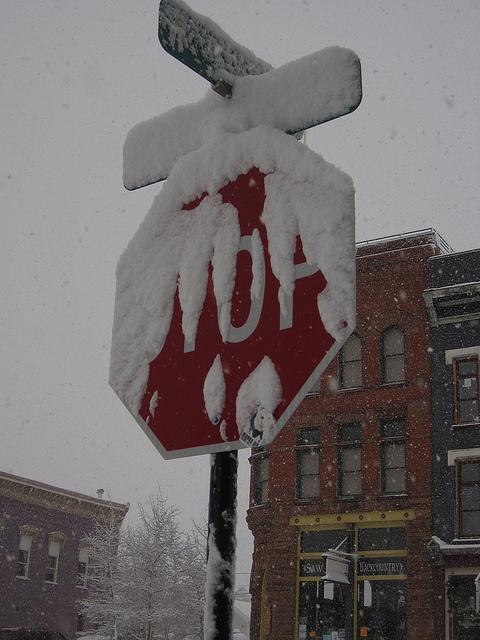How many cats are here?
Give a very brief answer. 0. 